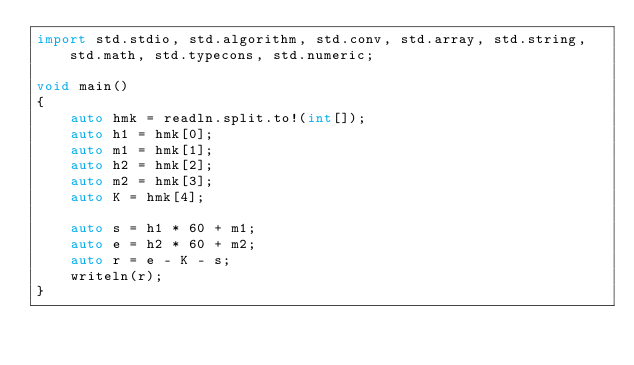<code> <loc_0><loc_0><loc_500><loc_500><_D_>import std.stdio, std.algorithm, std.conv, std.array, std.string, std.math, std.typecons, std.numeric;

void main()
{
    auto hmk = readln.split.to!(int[]);
    auto h1 = hmk[0];
    auto m1 = hmk[1];
    auto h2 = hmk[2];
    auto m2 = hmk[3];
    auto K = hmk[4];

    auto s = h1 * 60 + m1;
    auto e = h2 * 60 + m2;
    auto r = e - K - s;
    writeln(r);
}</code> 